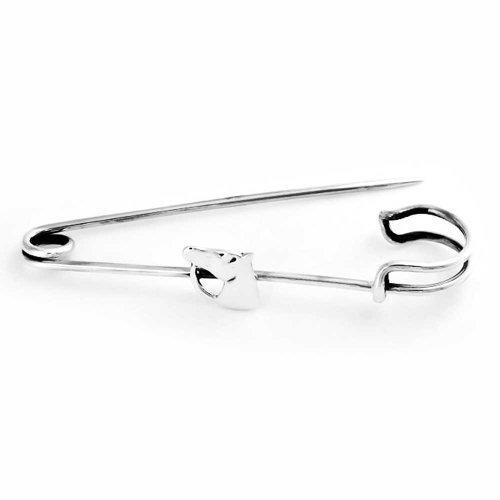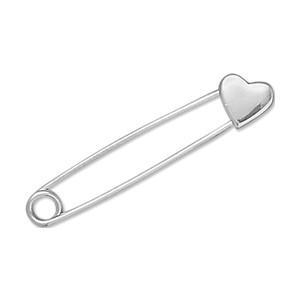The first image is the image on the left, the second image is the image on the right. For the images displayed, is the sentence "An image shows exactly one safety pin, which is strung with a horse-head shape charm." factually correct? Answer yes or no. Yes. The first image is the image on the left, the second image is the image on the right. For the images shown, is this caption "One image shows exactly two pins and both of those pins are closed." true? Answer yes or no. No. 